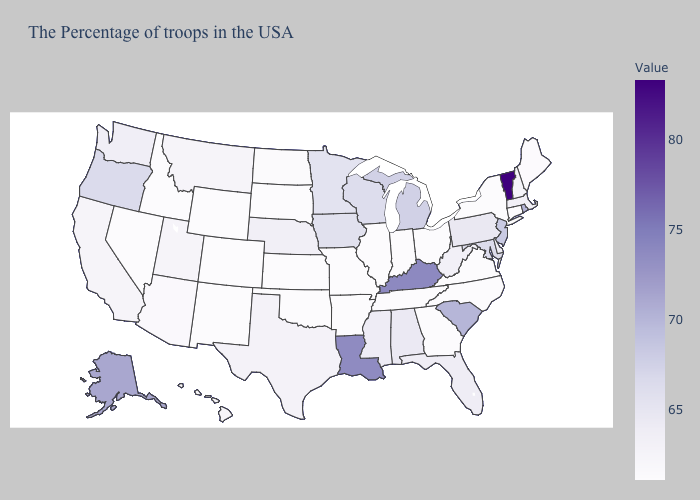Which states hav the highest value in the MidWest?
Write a very short answer. Michigan. Does the map have missing data?
Write a very short answer. No. Among the states that border New York , does Massachusetts have the lowest value?
Give a very brief answer. No. Which states have the lowest value in the USA?
Quick response, please. Connecticut, New York, Virginia, North Carolina, Ohio, Georgia, Indiana, Tennessee, Illinois, Missouri, Arkansas, Kansas, Oklahoma, South Dakota, Wyoming, Colorado, New Mexico, Idaho, Nevada. Does the map have missing data?
Concise answer only. No. 